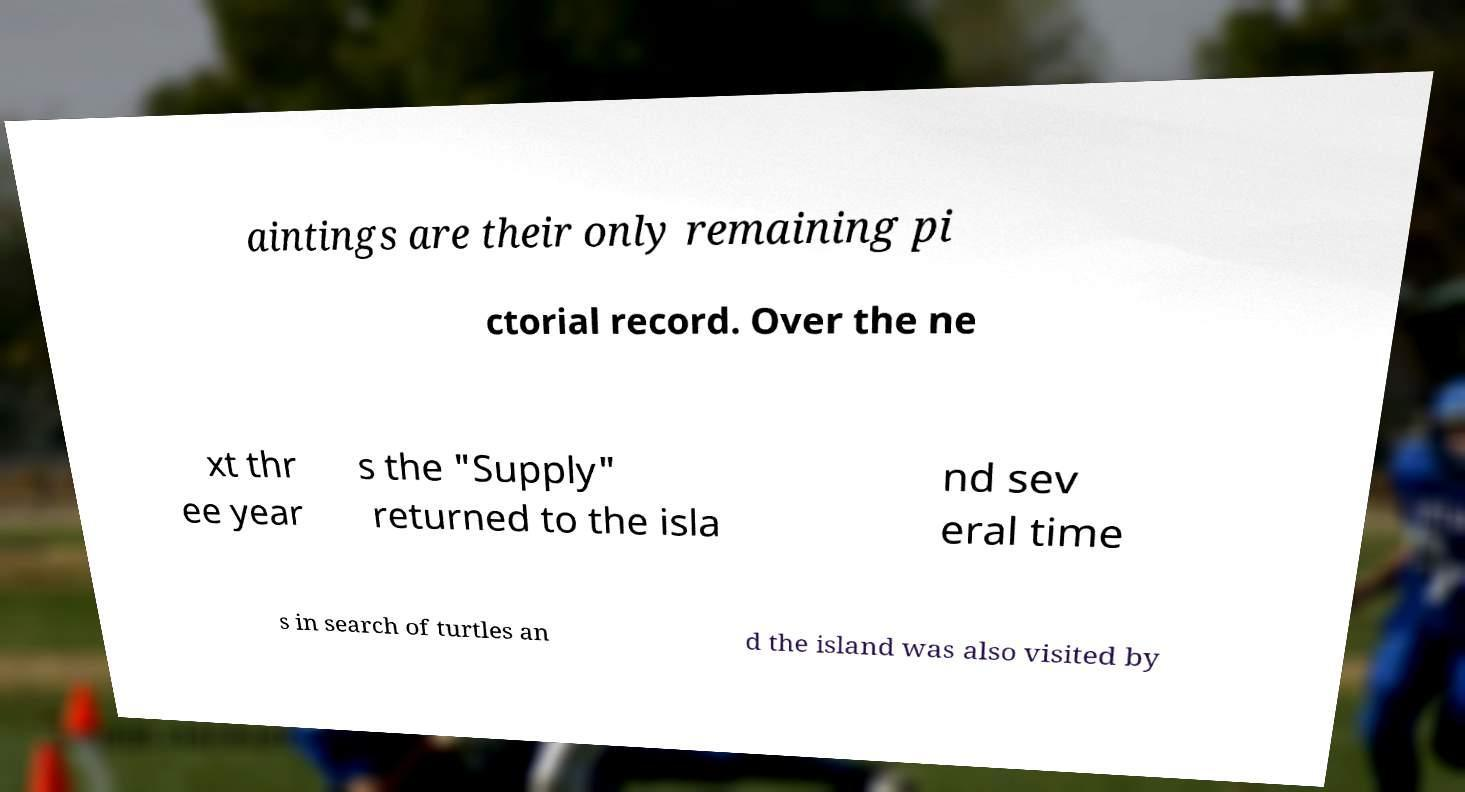Can you read and provide the text displayed in the image?This photo seems to have some interesting text. Can you extract and type it out for me? aintings are their only remaining pi ctorial record. Over the ne xt thr ee year s the "Supply" returned to the isla nd sev eral time s in search of turtles an d the island was also visited by 